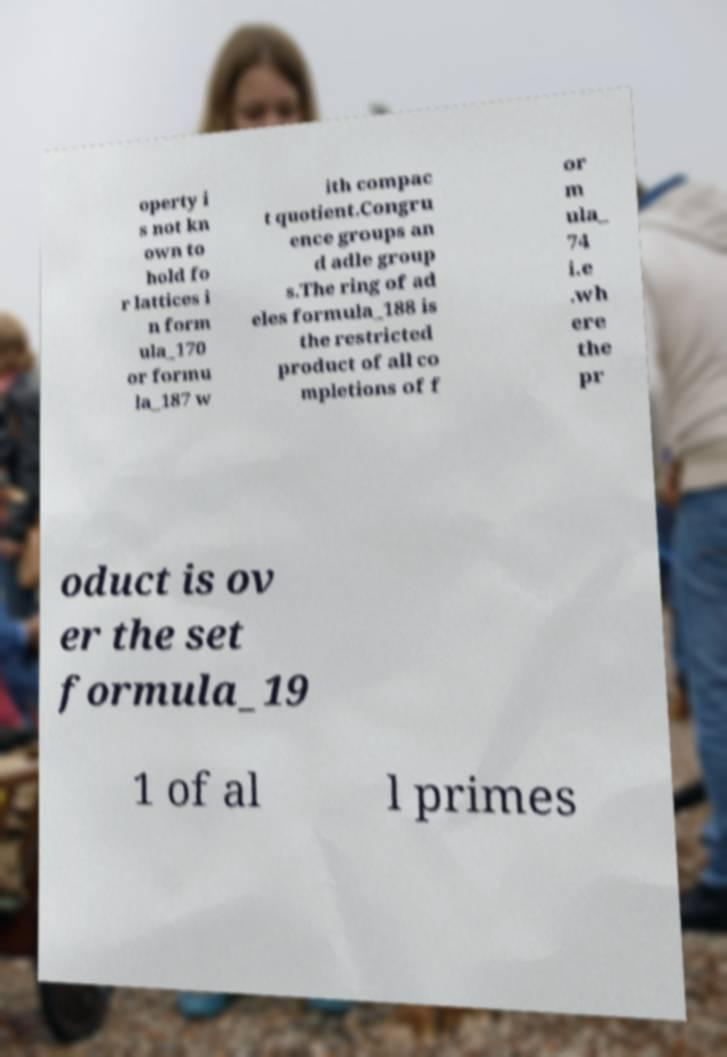There's text embedded in this image that I need extracted. Can you transcribe it verbatim? operty i s not kn own to hold fo r lattices i n form ula_170 or formu la_187 w ith compac t quotient.Congru ence groups an d adle group s.The ring of ad eles formula_188 is the restricted product of all co mpletions of f or m ula_ 74 i.e .wh ere the pr oduct is ov er the set formula_19 1 of al l primes 